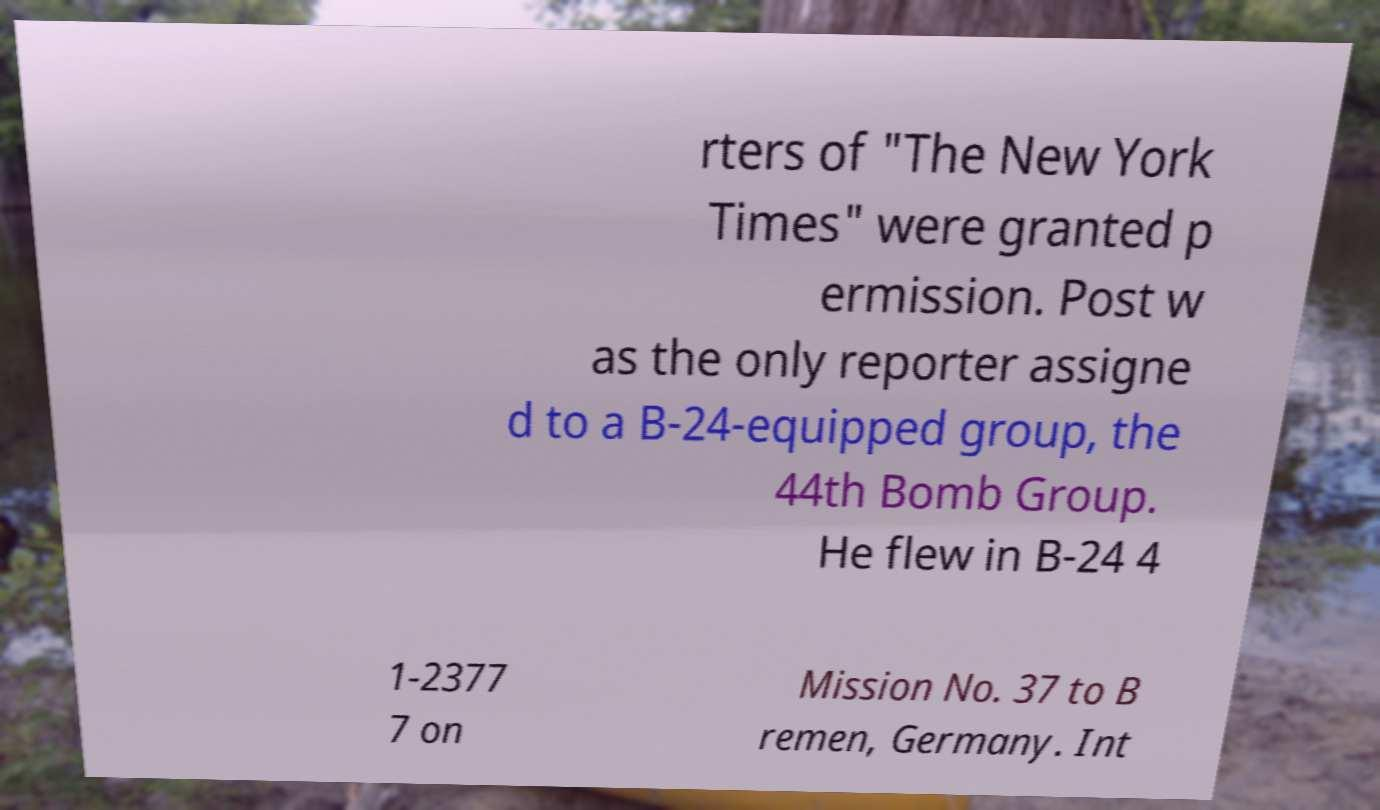For documentation purposes, I need the text within this image transcribed. Could you provide that? rters of "The New York Times" were granted p ermission. Post w as the only reporter assigne d to a B-24-equipped group, the 44th Bomb Group. He flew in B-24 4 1-2377 7 on Mission No. 37 to B remen, Germany. Int 